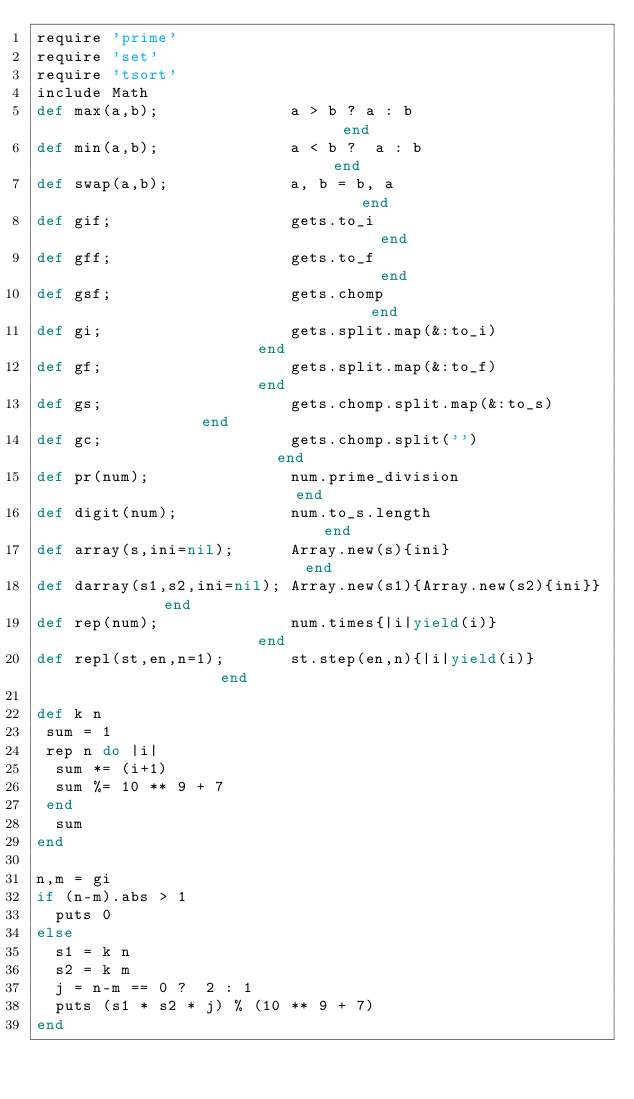Convert code to text. <code><loc_0><loc_0><loc_500><loc_500><_Ruby_>require 'prime'
require 'set'
require 'tsort'
include Math
def max(a,b);              a > b ? a : b                              end
def min(a,b);              a < b ?  a : b                             end
def swap(a,b);             a, b = b, a                                end
def gif;                   gets.to_i                                  end
def gff;                   gets.to_f                                  end
def gsf;                   gets.chomp                                 end
def gi;                    gets.split.map(&:to_i)                     end
def gf;                    gets.split.map(&:to_f)                     end
def gs;                    gets.chomp.split.map(&:to_s)               end
def gc;                    gets.chomp.split('')                       end
def pr(num);               num.prime_division                         end
def digit(num);            num.to_s.length                            end
def array(s,ini=nil);      Array.new(s){ini}                          end
def darray(s1,s2,ini=nil); Array.new(s1){Array.new(s2){ini}}          end
def rep(num);              num.times{|i|yield(i)}                     end
def repl(st,en,n=1);       st.step(en,n){|i|yield(i)}                 end

def k n
 sum = 1
 rep n do |i|
  sum *= (i+1)
  sum %= 10 ** 9 + 7
 end
  sum
end

n,m = gi
if (n-m).abs > 1
  puts 0
else
  s1 = k n
  s2 = k m
  j = n-m == 0 ?  2 : 1
  puts (s1 * s2 * j) % (10 ** 9 + 7)
end

</code> 